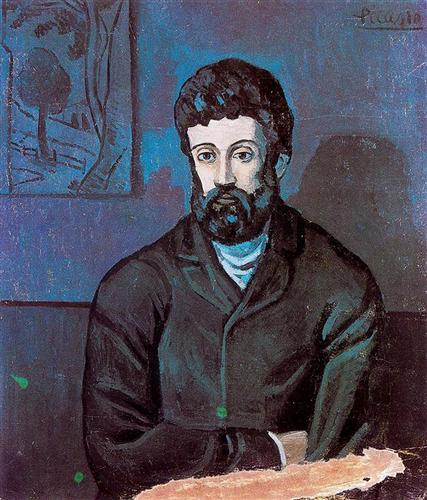Generate a poem inspired by this image. Beneath the blue-hued shadow's veil,
A man sits lost, where thoughts prevail.
In a world where whispers softly speak,
Of dreams long held, yet future's bleak.
A tree stands wise in sketched array,
Guarding secrets night and day.
Among the strokes of black and green,
Echoes of life in silent serene.
In his gaze, the depths unfold,
Stories of young and tales of old.
Art transcends the bounds of time,
In Picasso's hues, souls do climb. 